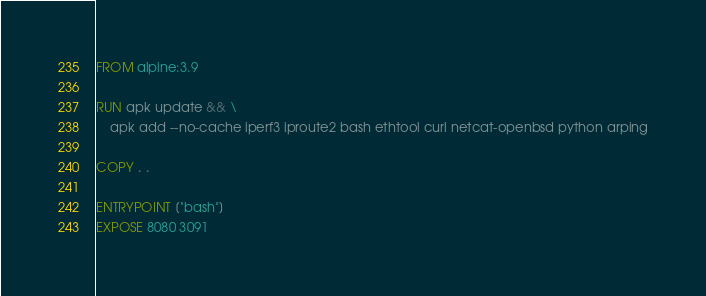Convert code to text. <code><loc_0><loc_0><loc_500><loc_500><_Dockerfile_>FROM alpine:3.9

RUN apk update && \
    apk add --no-cache iperf3 iproute2 bash ethtool curl netcat-openbsd python arping

COPY . .

ENTRYPOINT ["bash"]
EXPOSE 8080 3091
</code> 